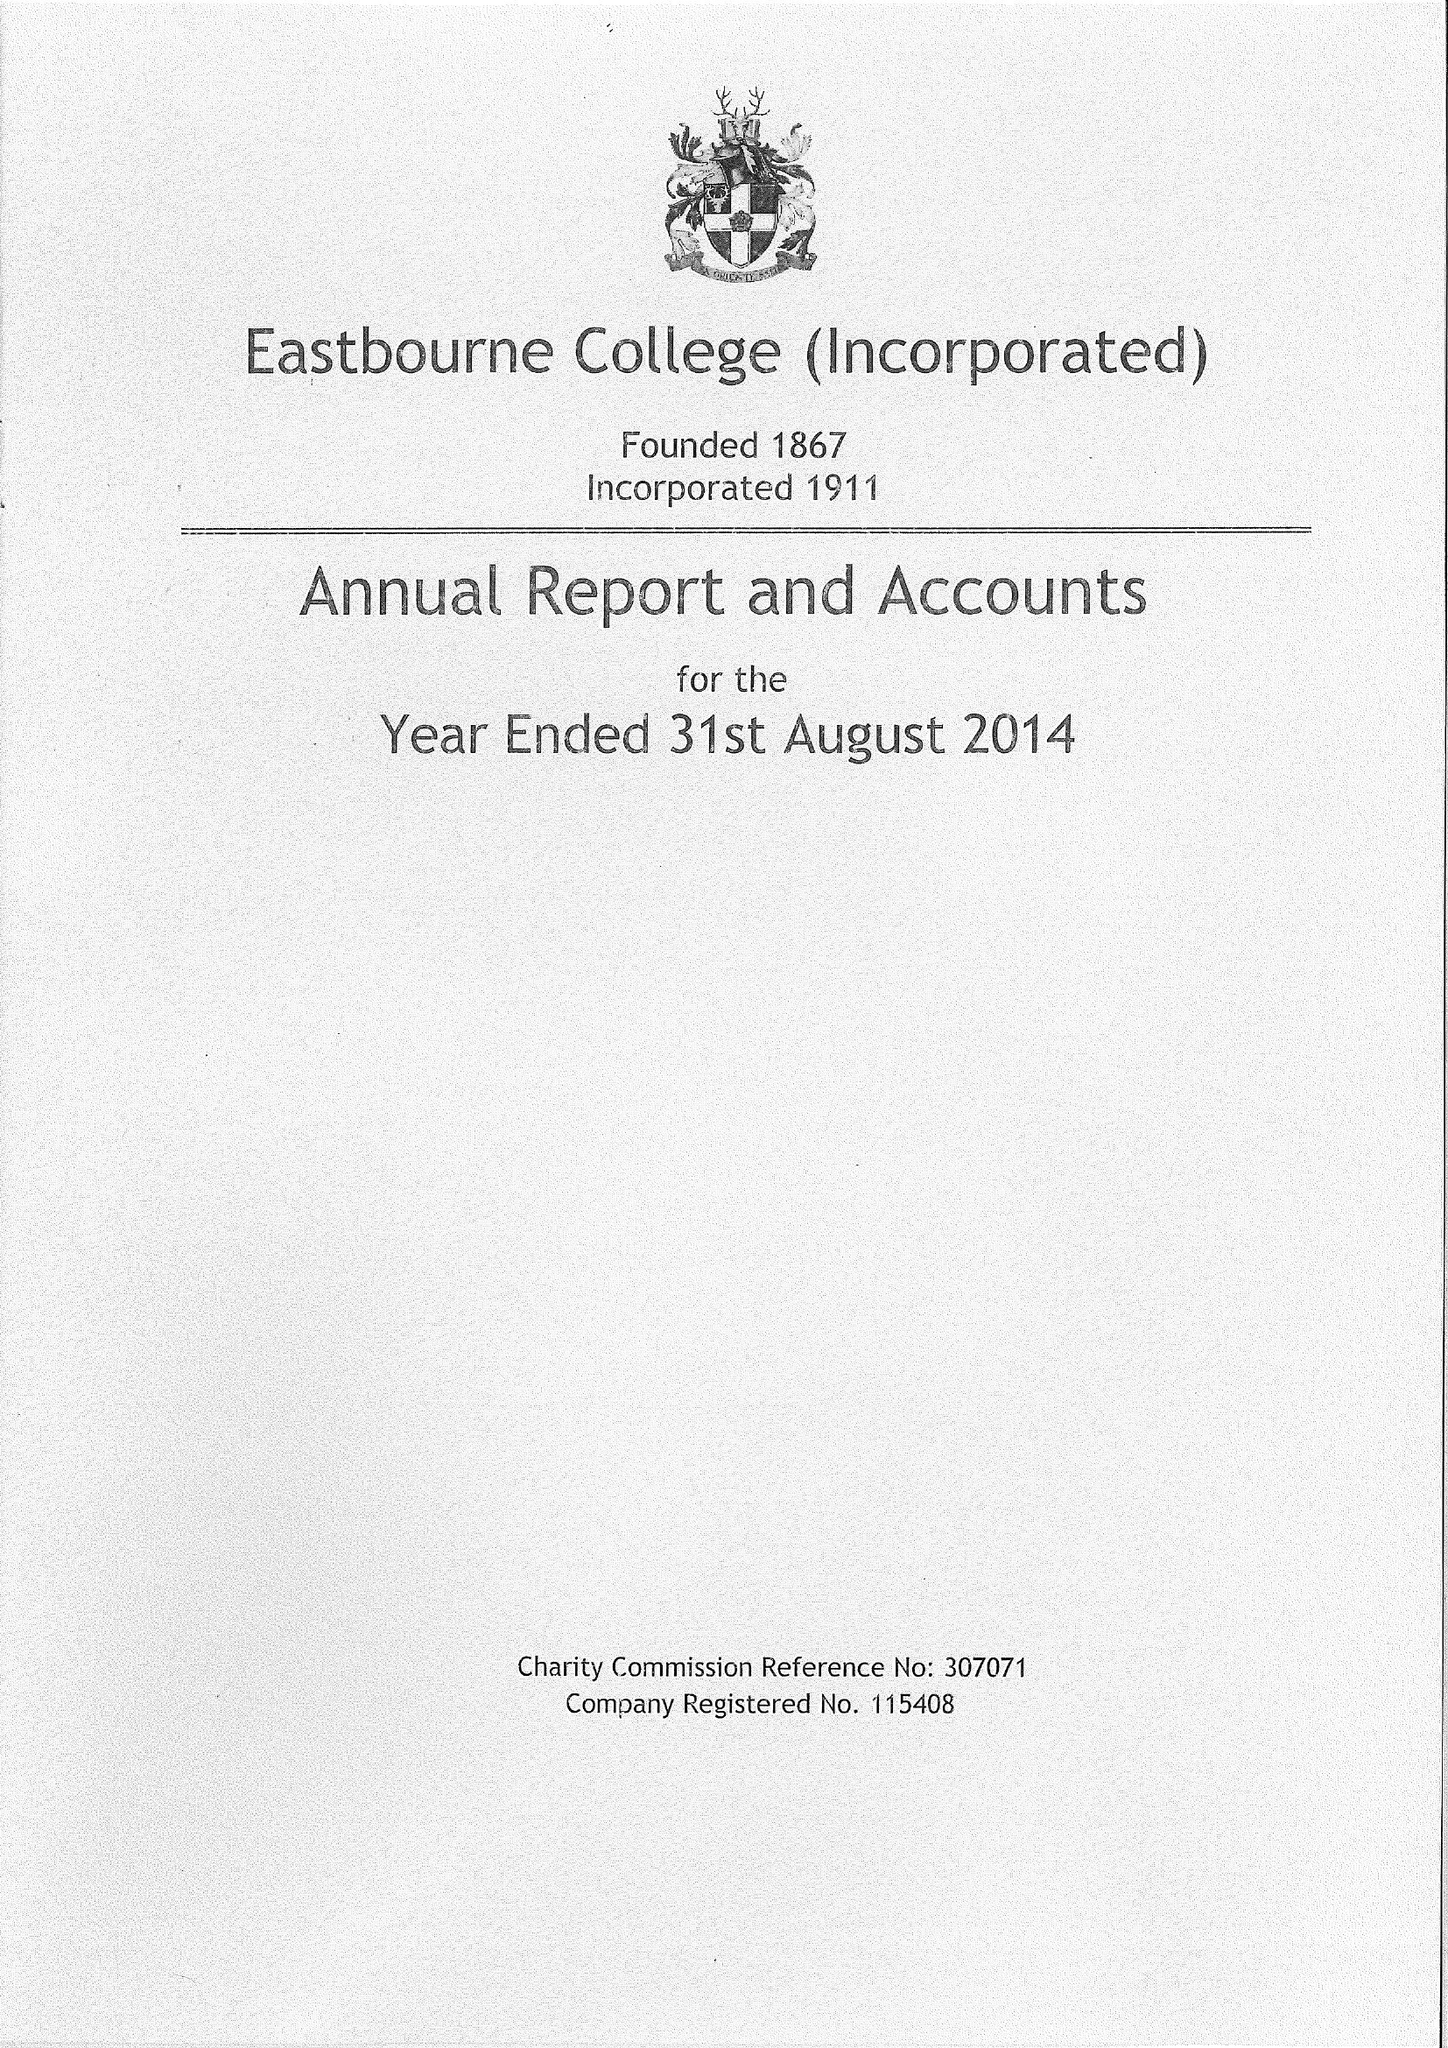What is the value for the address__post_town?
Answer the question using a single word or phrase. EASTBOURNE 